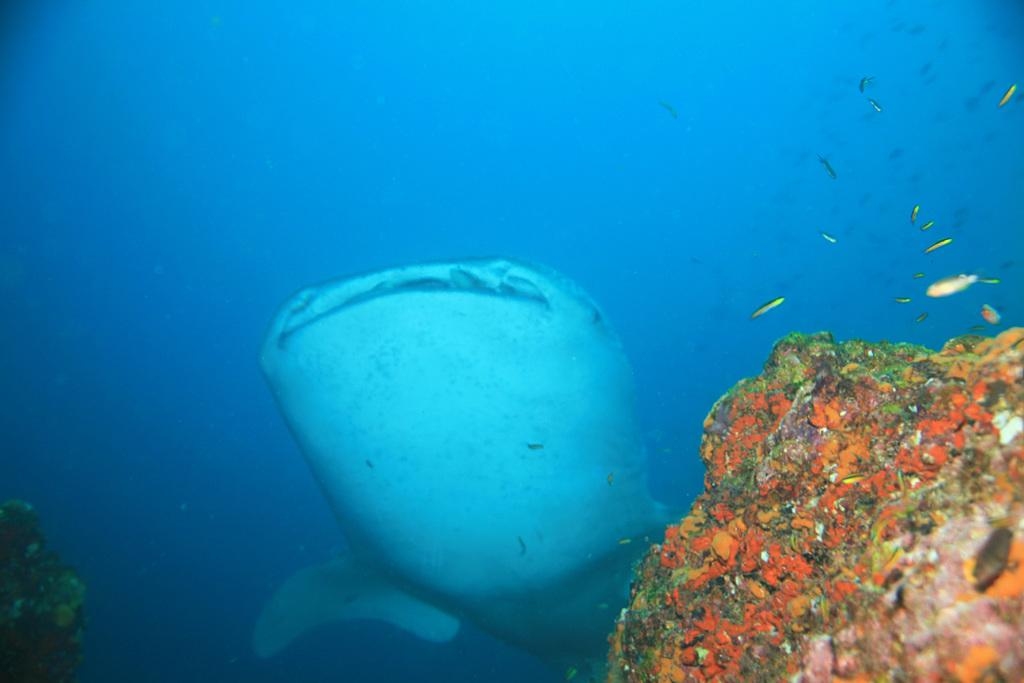What type of animal can be seen in the image? There is a water animal in the image. What other living organisms are present in the image? There are water plants and fishes in the image. What is the primary element visible in the image? There is water visible in the image. What type of leaf can be seen on the bed in the image? There is no bed or leaf present in the image; it features a water animal, water plants, fishes, and water. 